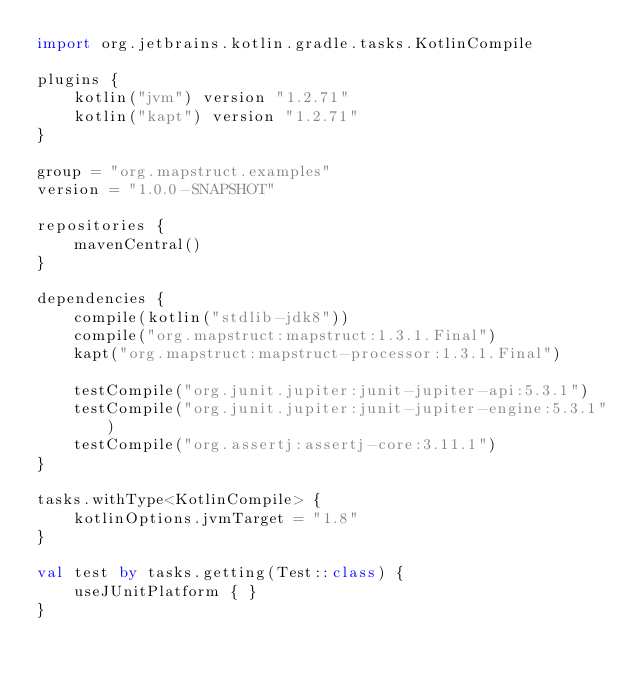<code> <loc_0><loc_0><loc_500><loc_500><_Kotlin_>import org.jetbrains.kotlin.gradle.tasks.KotlinCompile

plugins {
    kotlin("jvm") version "1.2.71"
    kotlin("kapt") version "1.2.71"
}

group = "org.mapstruct.examples"
version = "1.0.0-SNAPSHOT"

repositories {
    mavenCentral()
}

dependencies {
    compile(kotlin("stdlib-jdk8"))
    compile("org.mapstruct:mapstruct:1.3.1.Final")
    kapt("org.mapstruct:mapstruct-processor:1.3.1.Final")

    testCompile("org.junit.jupiter:junit-jupiter-api:5.3.1")
    testCompile("org.junit.jupiter:junit-jupiter-engine:5.3.1")
    testCompile("org.assertj:assertj-core:3.11.1")
}

tasks.withType<KotlinCompile> {
    kotlinOptions.jvmTarget = "1.8"
}

val test by tasks.getting(Test::class) {
    useJUnitPlatform { }
}</code> 